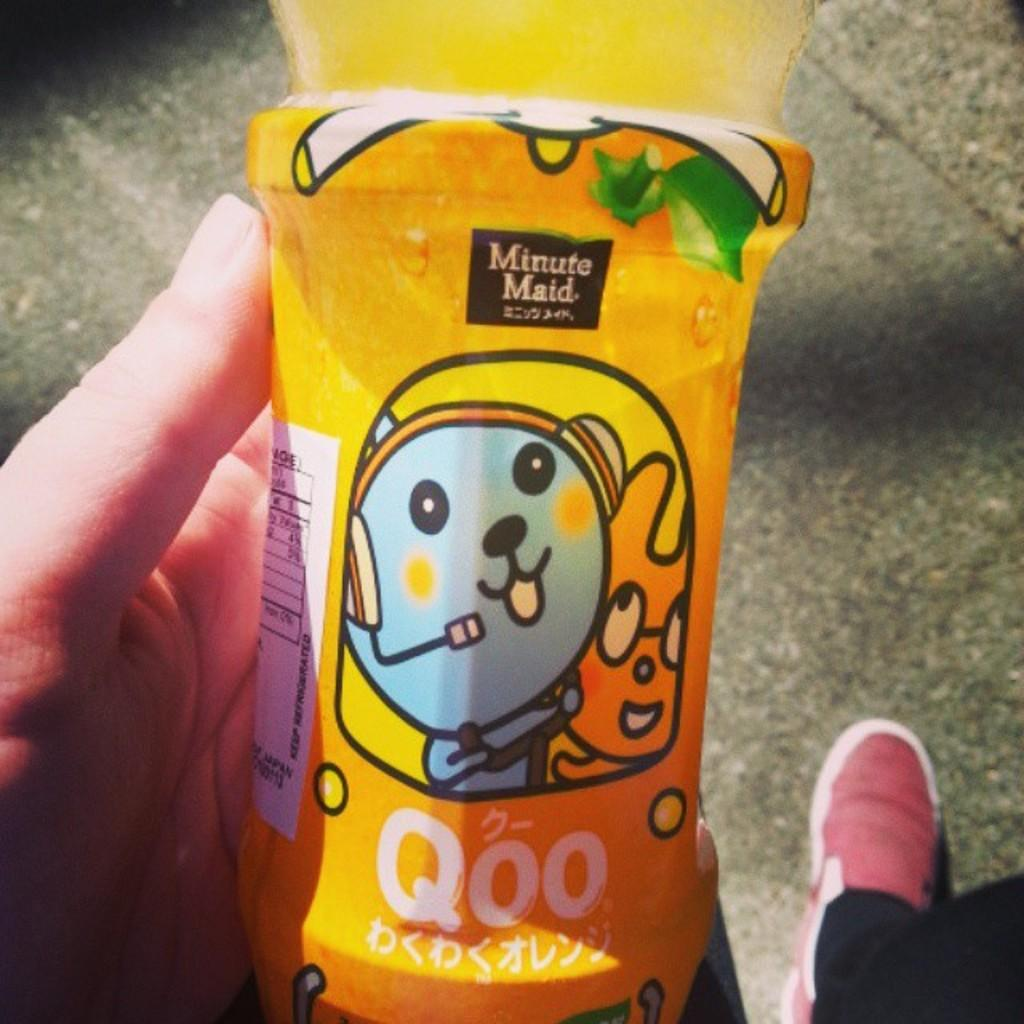What body part is visible in the image? There is a person's hand in the image. What else can be seen in the image related to the person? There is a person's leg with a shoe in the image. What is the person holding in their hand? The person is holding a bottle with a label in their hand. What information can be gathered from the label? Something is written on the label, and there is an image on the label. How many roses are present in the image? There are no roses visible in the image. Can you describe the frogs on the person's leg? There are no frogs present in the image. 